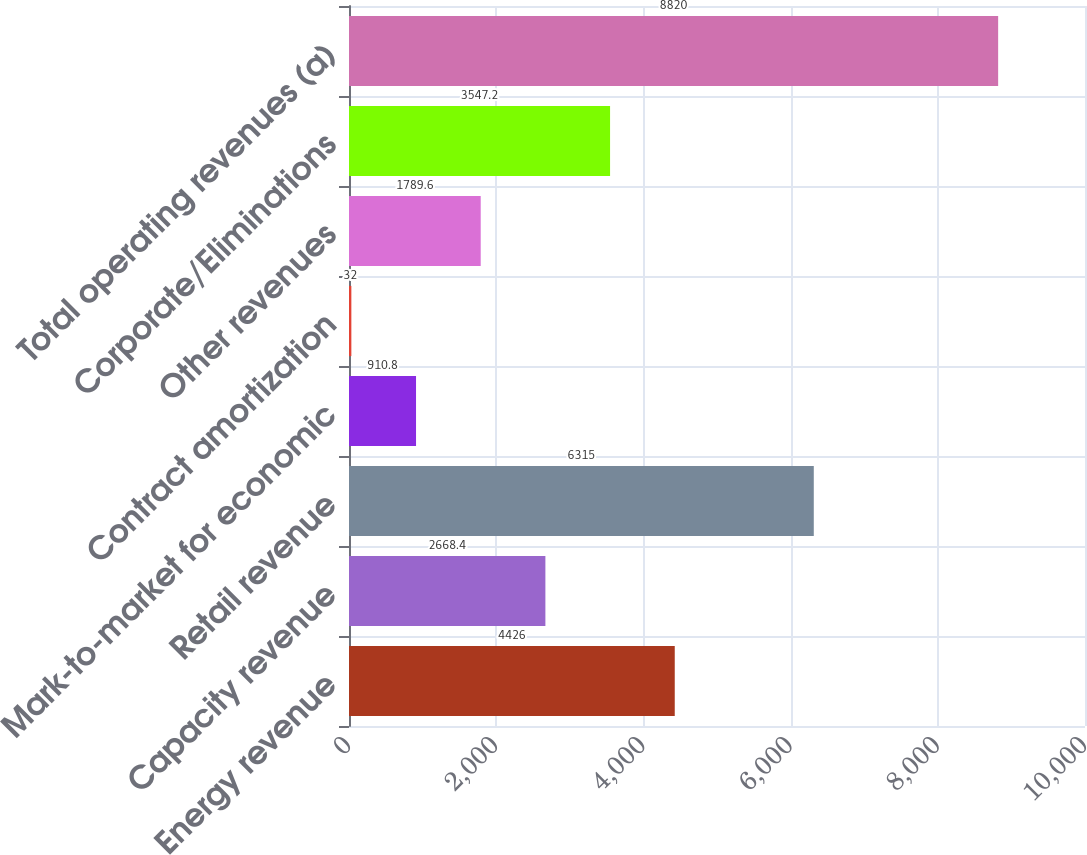Convert chart to OTSL. <chart><loc_0><loc_0><loc_500><loc_500><bar_chart><fcel>Energy revenue<fcel>Capacity revenue<fcel>Retail revenue<fcel>Mark-to-market for economic<fcel>Contract amortization<fcel>Other revenues<fcel>Corporate/Eliminations<fcel>Total operating revenues (a)<nl><fcel>4426<fcel>2668.4<fcel>6315<fcel>910.8<fcel>32<fcel>1789.6<fcel>3547.2<fcel>8820<nl></chart> 